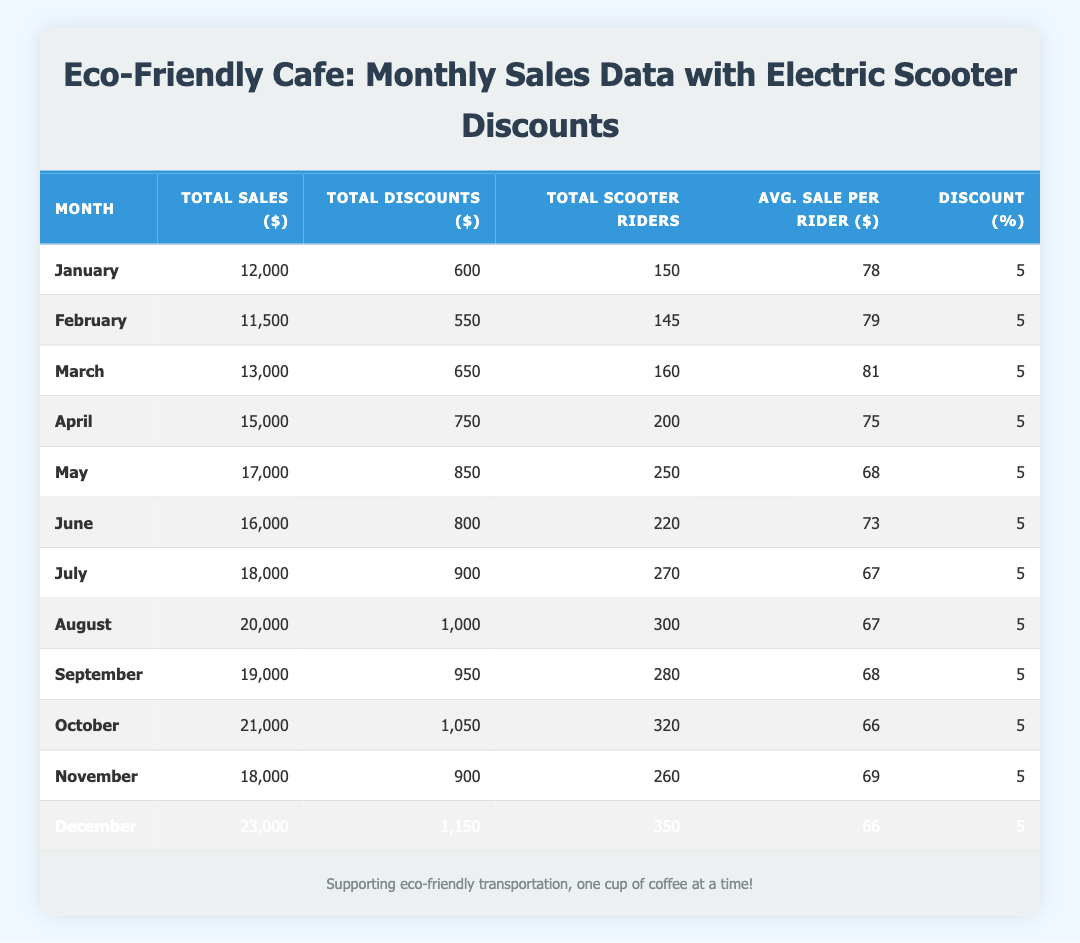What was the total sales in December? Looking at the row for December, the column under total sales shows 23,000.
Answer: 23,000 How many scooter riders visited the cafe in March? Referring to the March row, the number of total scooter riders is listed as 160.
Answer: 160 What is the average sale per rider in July? In the July row, the average sale per rider is indicated as 67.
Answer: 67 Which month had the highest total discounts given? Upon examining all the total discounts, December has the highest amount at 1,150.
Answer: December Calculate the total sales from April to June. Sum the total sales for those months: April (15,000) + May (17,000) + June (16,000) = 48,000.
Answer: 48,000 Was the average sale per rider in October lower than the average in September? The average sale per rider in October is 66, and in September it is 68. Since 66 is less than 68, the statement is true.
Answer: Yes What was the total number of scooter riders across all months in the data? To find this, sum the total scooter riders: 150 + 145 + 160 + 200 + 250 + 220 + 270 + 300 + 280 + 320 + 260 + 350 = 2,655.
Answer: 2,655 What is the average discount percentage across all months? The discount percentage is consistently 5% for each month, so the average remains 5%.
Answer: 5 Which month had the highest average sale per rider? By comparing average sales per rider, March with 81 stands out as the highest value.
Answer: March 